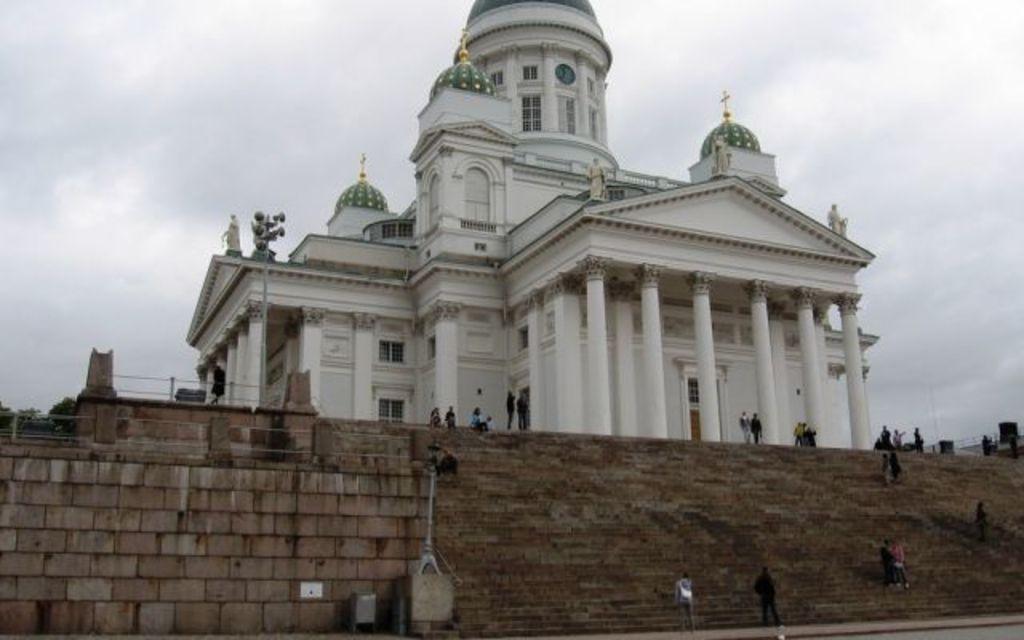Can you describe this image briefly? In this picture we can see stairs and a few people. There are trees and other objects. We can see pillars, cross symbols, sculpture and a few things on the building. We can see the sky. 